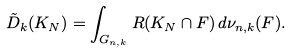Convert formula to latex. <formula><loc_0><loc_0><loc_500><loc_500>\tilde { D } _ { k } ( K _ { N } ) = \int _ { G _ { n , k } } R ( K _ { N } \cap F ) \, d \nu _ { n , k } ( F ) .</formula> 